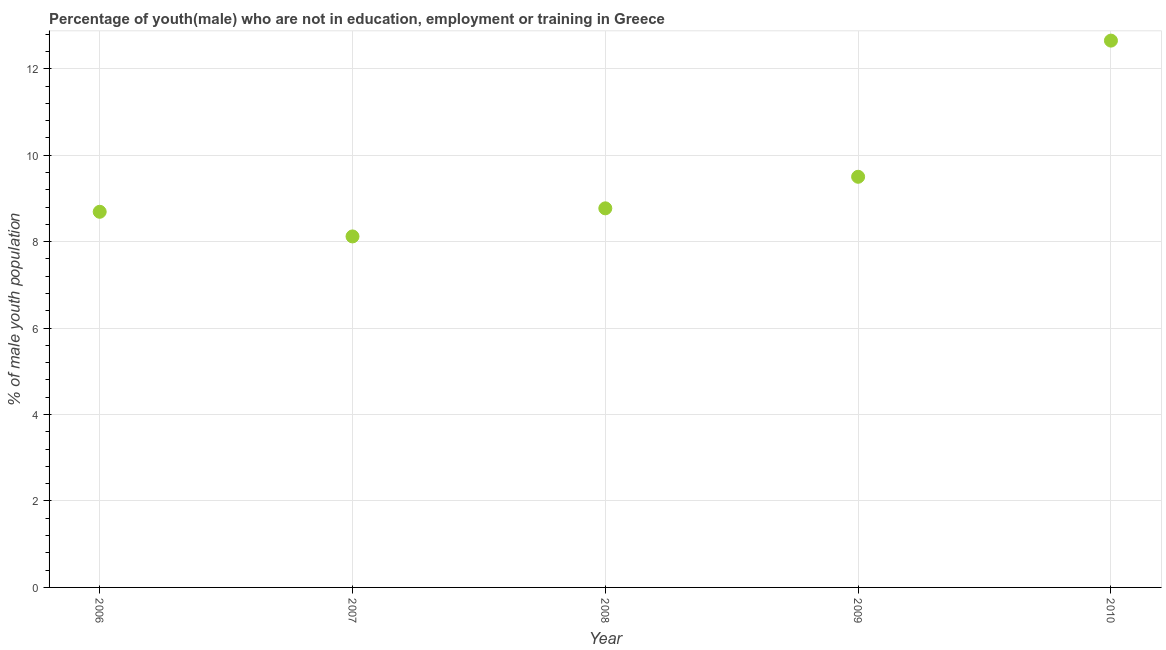Across all years, what is the maximum unemployed male youth population?
Your answer should be very brief. 12.65. Across all years, what is the minimum unemployed male youth population?
Your answer should be very brief. 8.12. In which year was the unemployed male youth population maximum?
Offer a terse response. 2010. In which year was the unemployed male youth population minimum?
Make the answer very short. 2007. What is the sum of the unemployed male youth population?
Keep it short and to the point. 47.73. What is the difference between the unemployed male youth population in 2008 and 2010?
Provide a short and direct response. -3.88. What is the average unemployed male youth population per year?
Your response must be concise. 9.55. What is the median unemployed male youth population?
Offer a very short reply. 8.77. In how many years, is the unemployed male youth population greater than 2.4 %?
Your response must be concise. 5. Do a majority of the years between 2009 and 2006 (inclusive) have unemployed male youth population greater than 6.8 %?
Offer a terse response. Yes. What is the ratio of the unemployed male youth population in 2006 to that in 2008?
Provide a succinct answer. 0.99. Is the difference between the unemployed male youth population in 2007 and 2008 greater than the difference between any two years?
Give a very brief answer. No. What is the difference between the highest and the second highest unemployed male youth population?
Give a very brief answer. 3.15. What is the difference between the highest and the lowest unemployed male youth population?
Your answer should be very brief. 4.53. Does the unemployed male youth population monotonically increase over the years?
Your answer should be compact. No. How many dotlines are there?
Offer a terse response. 1. How many years are there in the graph?
Keep it short and to the point. 5. What is the difference between two consecutive major ticks on the Y-axis?
Provide a succinct answer. 2. Does the graph contain any zero values?
Your answer should be very brief. No. What is the title of the graph?
Your response must be concise. Percentage of youth(male) who are not in education, employment or training in Greece. What is the label or title of the X-axis?
Provide a succinct answer. Year. What is the label or title of the Y-axis?
Your response must be concise. % of male youth population. What is the % of male youth population in 2006?
Keep it short and to the point. 8.69. What is the % of male youth population in 2007?
Keep it short and to the point. 8.12. What is the % of male youth population in 2008?
Your answer should be compact. 8.77. What is the % of male youth population in 2010?
Your answer should be compact. 12.65. What is the difference between the % of male youth population in 2006 and 2007?
Provide a succinct answer. 0.57. What is the difference between the % of male youth population in 2006 and 2008?
Ensure brevity in your answer.  -0.08. What is the difference between the % of male youth population in 2006 and 2009?
Offer a terse response. -0.81. What is the difference between the % of male youth population in 2006 and 2010?
Make the answer very short. -3.96. What is the difference between the % of male youth population in 2007 and 2008?
Make the answer very short. -0.65. What is the difference between the % of male youth population in 2007 and 2009?
Your response must be concise. -1.38. What is the difference between the % of male youth population in 2007 and 2010?
Keep it short and to the point. -4.53. What is the difference between the % of male youth population in 2008 and 2009?
Make the answer very short. -0.73. What is the difference between the % of male youth population in 2008 and 2010?
Your response must be concise. -3.88. What is the difference between the % of male youth population in 2009 and 2010?
Offer a terse response. -3.15. What is the ratio of the % of male youth population in 2006 to that in 2007?
Keep it short and to the point. 1.07. What is the ratio of the % of male youth population in 2006 to that in 2009?
Make the answer very short. 0.92. What is the ratio of the % of male youth population in 2006 to that in 2010?
Keep it short and to the point. 0.69. What is the ratio of the % of male youth population in 2007 to that in 2008?
Give a very brief answer. 0.93. What is the ratio of the % of male youth population in 2007 to that in 2009?
Keep it short and to the point. 0.85. What is the ratio of the % of male youth population in 2007 to that in 2010?
Your answer should be very brief. 0.64. What is the ratio of the % of male youth population in 2008 to that in 2009?
Provide a succinct answer. 0.92. What is the ratio of the % of male youth population in 2008 to that in 2010?
Offer a very short reply. 0.69. What is the ratio of the % of male youth population in 2009 to that in 2010?
Provide a succinct answer. 0.75. 